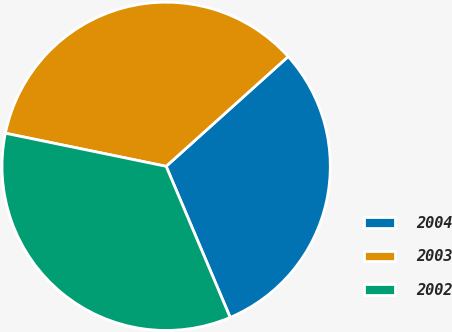<chart> <loc_0><loc_0><loc_500><loc_500><pie_chart><fcel>2004<fcel>2003<fcel>2002<nl><fcel>30.28%<fcel>35.11%<fcel>34.61%<nl></chart> 